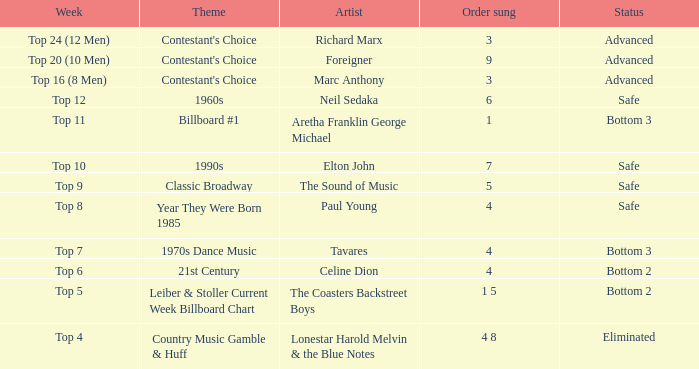In which week did the participant end up in the bottom 2 with a celine dion track? Top 6. 